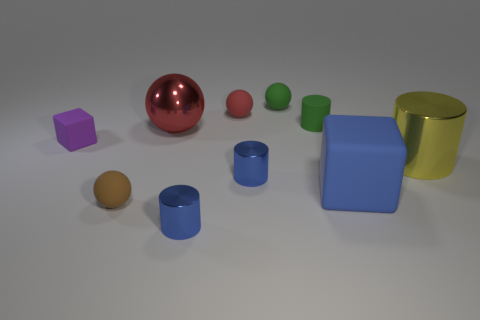The green ball has what size?
Make the answer very short. Small. Do the red shiny object and the blue matte thing have the same size?
Offer a terse response. Yes. How many things are cylinders that are in front of the large sphere or metallic objects left of the tiny green matte cylinder?
Give a very brief answer. 4. What number of large blue rubber objects are on the left side of the large shiny object in front of the matte block that is behind the big shiny cylinder?
Make the answer very short. 1. What is the size of the blue thing that is behind the big matte cube?
Make the answer very short. Small. How many cylinders are the same size as the blue matte block?
Your answer should be compact. 1. There is a shiny ball; does it have the same size as the matte ball that is behind the small red ball?
Your answer should be compact. No. What number of things are large gray shiny cubes or blue cylinders?
Your answer should be very brief. 2. What number of small objects have the same color as the large sphere?
Your response must be concise. 1. The brown matte object that is the same size as the green matte ball is what shape?
Your answer should be very brief. Sphere. 